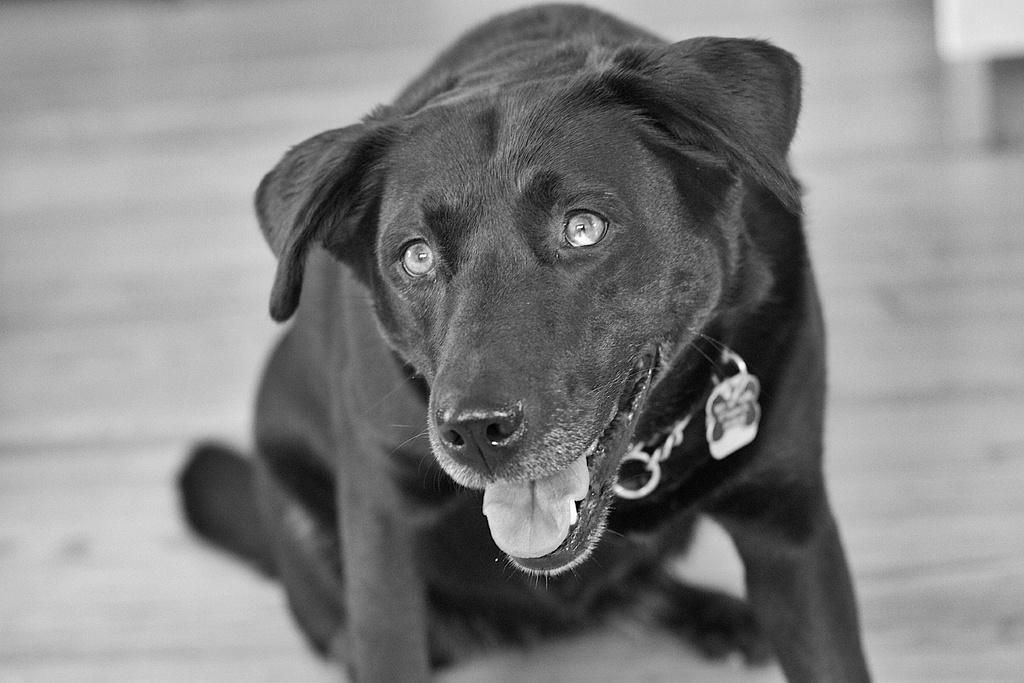What type of animal is in the picture? There is a dog in the picture. Where is the dog located in the image? The dog is sitting on the floor. What color is the floor in the image? The floor is black in color. What is attached to the dog's neck? The dog has a chain around its neck. What is hanging from the chain on the dog's neck? The dog has a locket on the chain. What type of frame is around the dog in the image? There is no frame around the dog in the image; it is a photograph or illustration of the dog without any frame. 